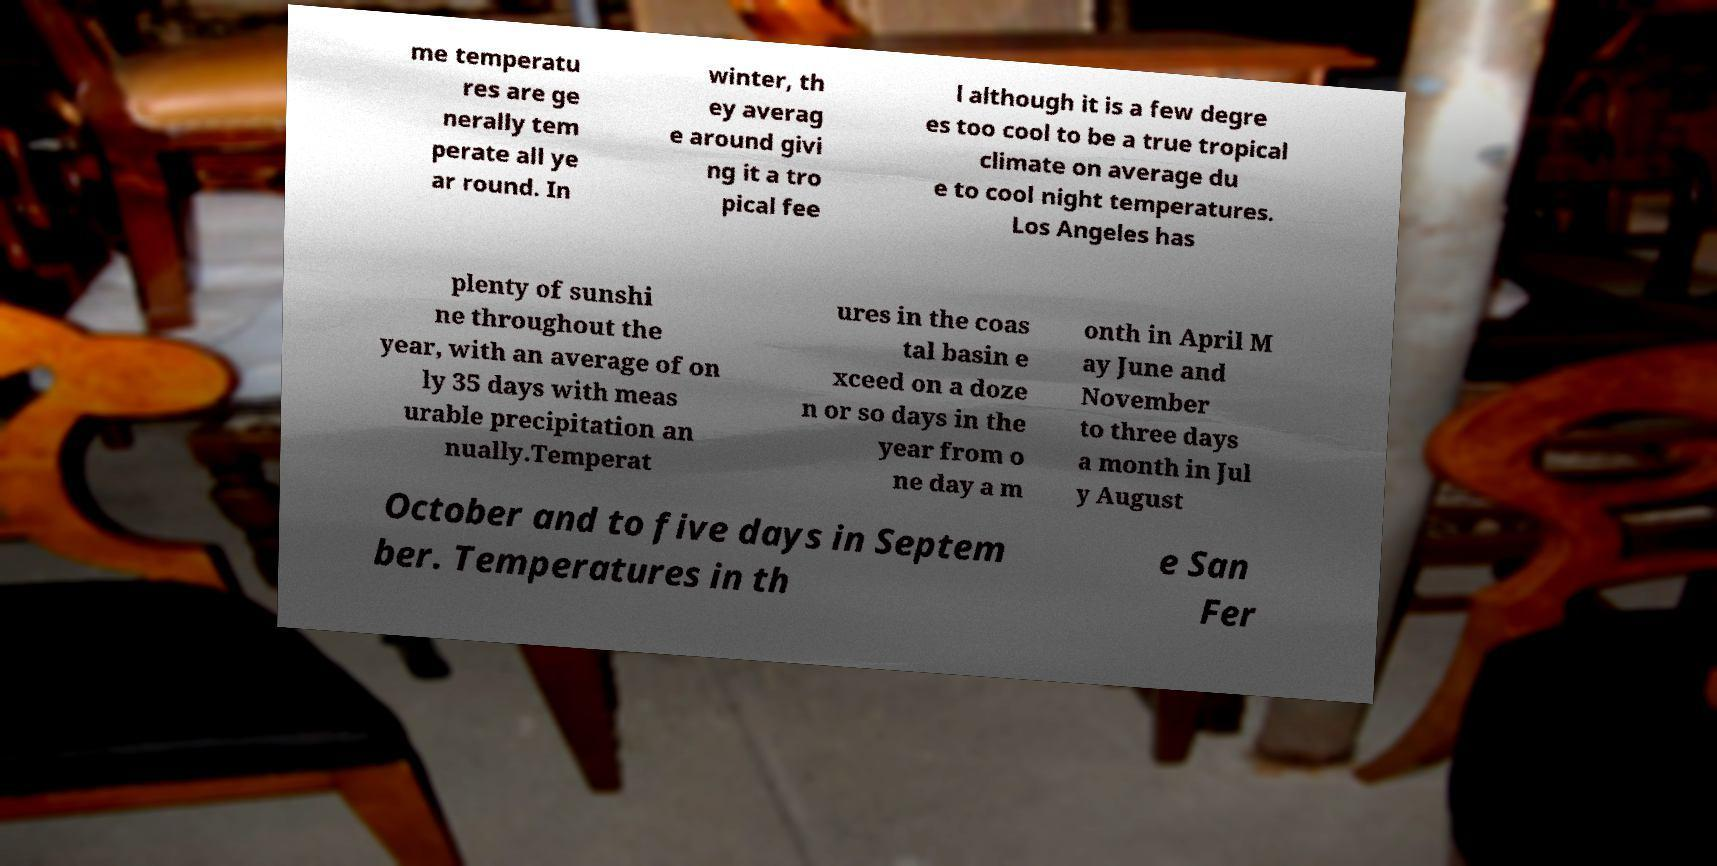What messages or text are displayed in this image? I need them in a readable, typed format. me temperatu res are ge nerally tem perate all ye ar round. In winter, th ey averag e around givi ng it a tro pical fee l although it is a few degre es too cool to be a true tropical climate on average du e to cool night temperatures. Los Angeles has plenty of sunshi ne throughout the year, with an average of on ly 35 days with meas urable precipitation an nually.Temperat ures in the coas tal basin e xceed on a doze n or so days in the year from o ne day a m onth in April M ay June and November to three days a month in Jul y August October and to five days in Septem ber. Temperatures in th e San Fer 